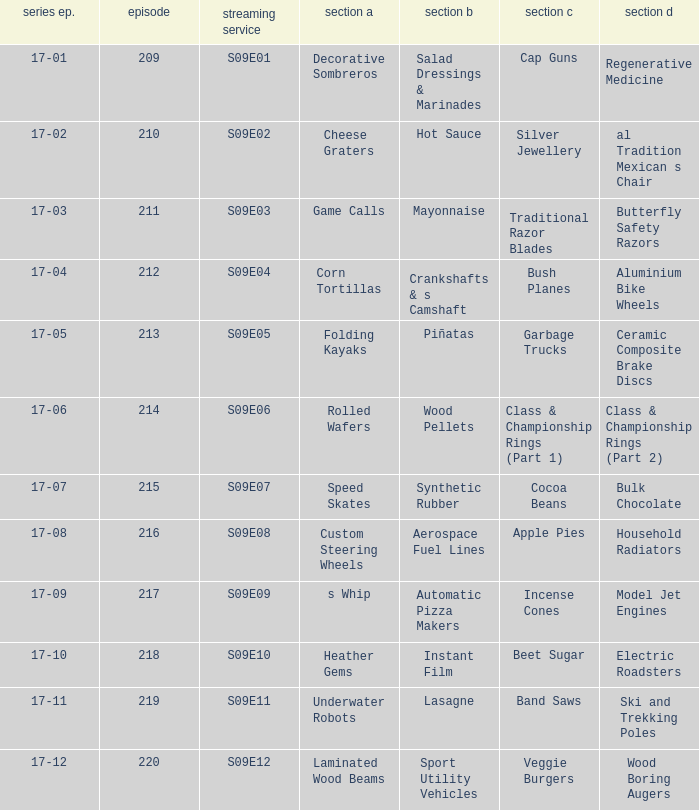Are rolled wafers in many episodes 17-06. 